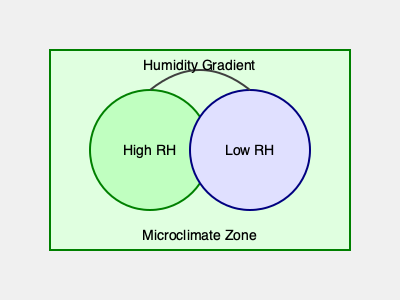In a microclimate created by grouping high and low relative humidity (RH) loving plants, what is the expected relationship between the vapor pressure deficit (VPD) in the high RH zone ($VPD_H$) and the low RH zone ($VPD_L$), assuming constant temperature? Express your answer as an inequality. To understand the relationship between vapor pressure deficit (VPD) in high and low relative humidity (RH) zones, let's follow these steps:

1. Recall that VPD is the difference between the saturation vapor pressure and the actual vapor pressure of the air. It's calculated as:

   $VPD = VP_{sat} - VP_{act}$

   Where $VP_{sat}$ is the saturation vapor pressure and $VP_{act}$ is the actual vapor pressure.

2. At a constant temperature, $VP_{sat}$ remains the same for both zones. The difference lies in $VP_{act}$.

3. Relative Humidity (RH) is defined as:

   $RH = \frac{VP_{act}}{VP_{sat}} \times 100\%$

4. In the high RH zone, $VP_{act}$ is closer to $VP_{sat}$, resulting in a smaller difference between them.

5. In the low RH zone, $VP_{act}$ is further from $VP_{sat}$, resulting in a larger difference.

6. Therefore, at constant temperature:

   $VPD_H = VP_{sat} - VP_{act,H}$ (smaller difference)
   $VPD_L = VP_{sat} - VP_{act,L}$ (larger difference)

7. Since the difference is smaller in the high RH zone and larger in the low RH zone, we can conclude:

   $VPD_H < VPD_L$

This inequality reflects that plants in the high RH zone experience less water loss through transpiration compared to those in the low RH zone, which is why they prefer higher humidity environments.
Answer: $VPD_H < VPD_L$ 